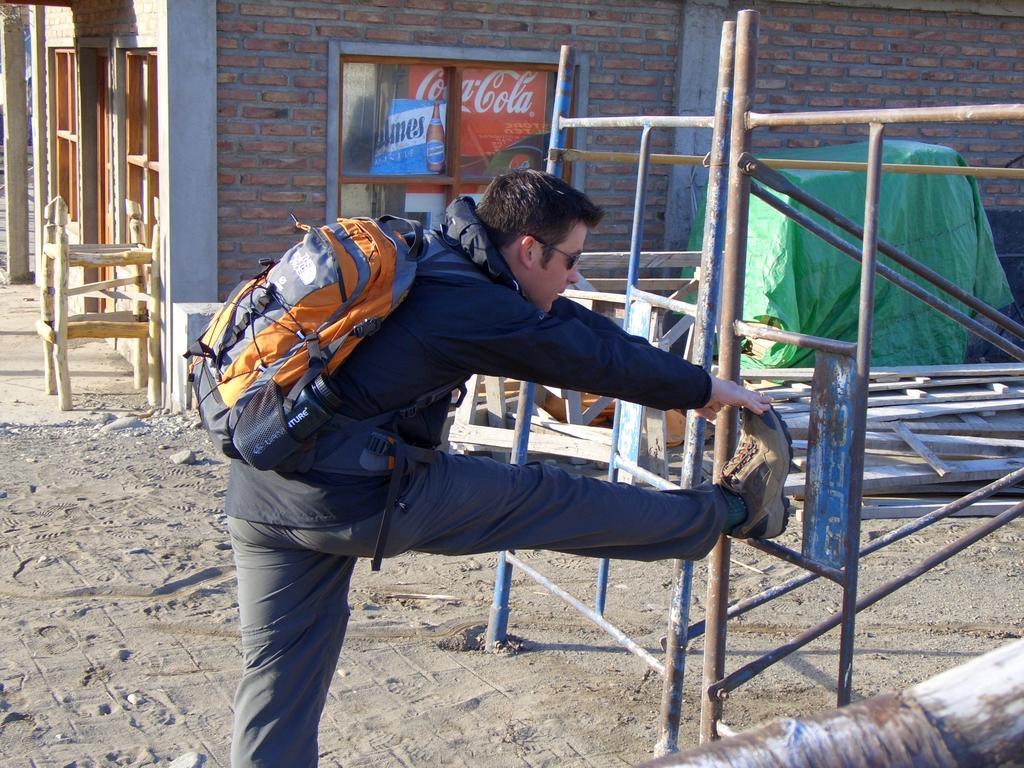Can you describe this image briefly? In this image there is a man stretching his legs by keeping it on the iron rod. In the background there is a wall with the wooden windows. At the bottom there is sand. On the right side there are iron rods. On the ground there are wooden sticks. On the right side top corner there is a wall to which there is some object attached to it. In the window we can see the hoardings. 